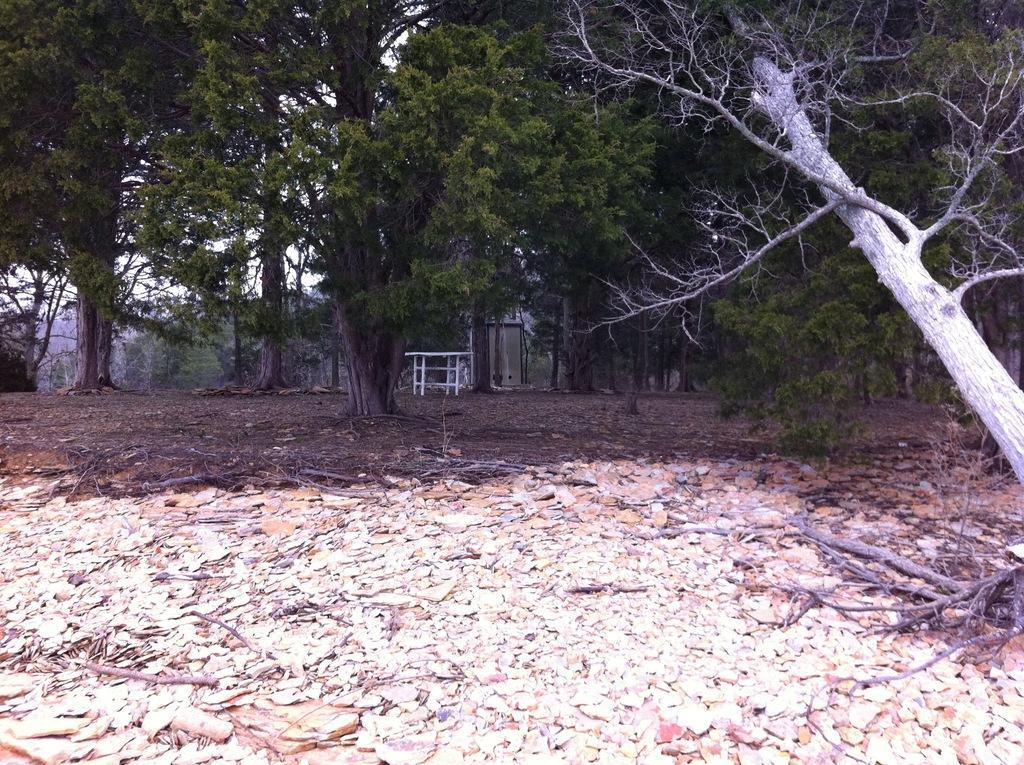Can you describe this image briefly? In this image, we can see so many trees, table. Here we can see dry leaves and twigs. Background there is a sky. 